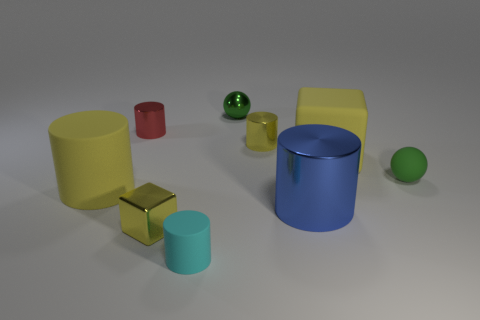Subtract all metallic cylinders. How many cylinders are left? 2 Subtract all red cylinders. How many cylinders are left? 4 Subtract 1 cylinders. How many cylinders are left? 4 Add 1 balls. How many objects exist? 10 Subtract all purple cylinders. Subtract all gray cubes. How many cylinders are left? 5 Subtract all cubes. How many objects are left? 7 Add 2 small shiny things. How many small shiny things are left? 6 Add 6 tiny purple cylinders. How many tiny purple cylinders exist? 6 Subtract 0 cyan balls. How many objects are left? 9 Subtract all big blue cylinders. Subtract all rubber objects. How many objects are left? 4 